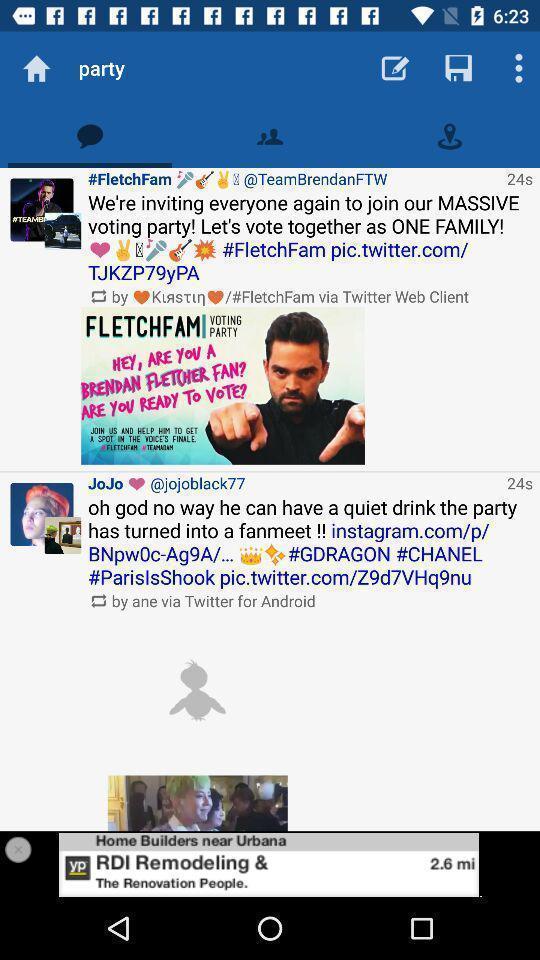Describe the visual elements of this screenshot. Screen displaying posts. 